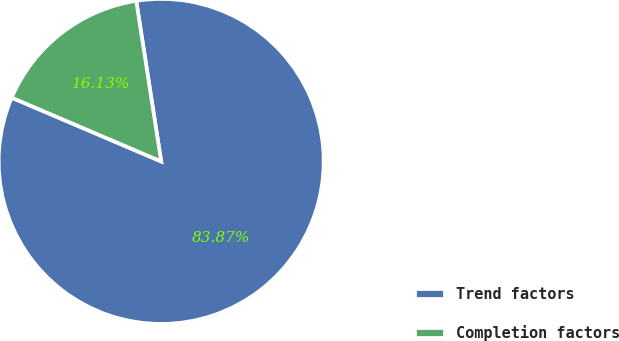<chart> <loc_0><loc_0><loc_500><loc_500><pie_chart><fcel>Trend factors<fcel>Completion factors<nl><fcel>83.87%<fcel>16.13%<nl></chart> 